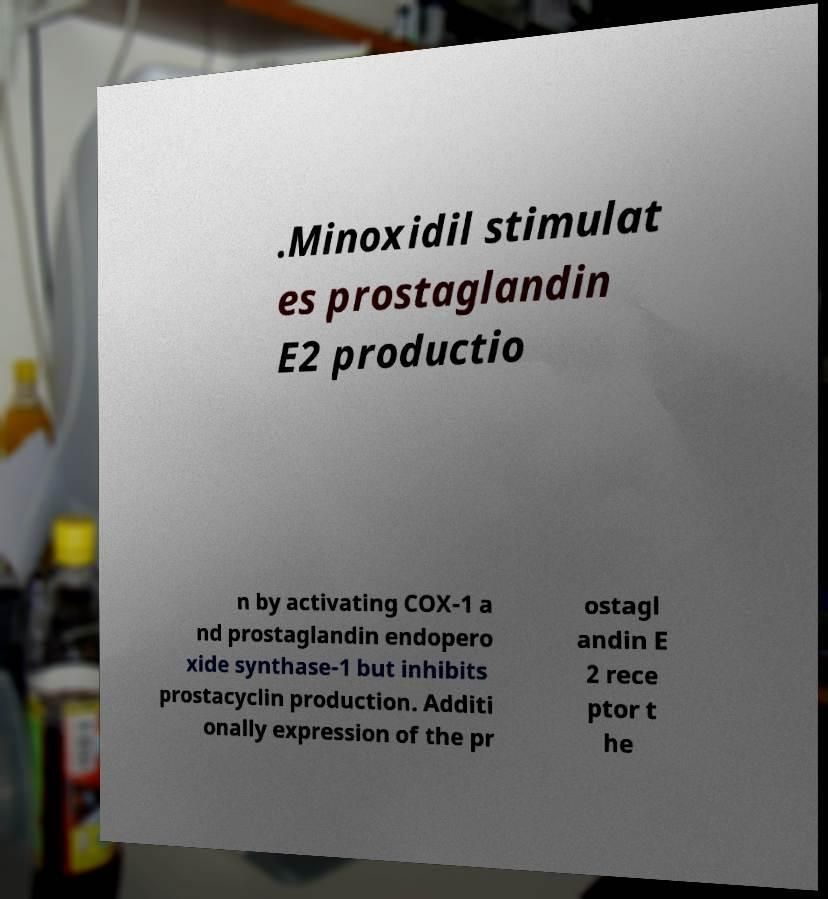What messages or text are displayed in this image? I need them in a readable, typed format. .Minoxidil stimulat es prostaglandin E2 productio n by activating COX-1 a nd prostaglandin endopero xide synthase-1 but inhibits prostacyclin production. Additi onally expression of the pr ostagl andin E 2 rece ptor t he 